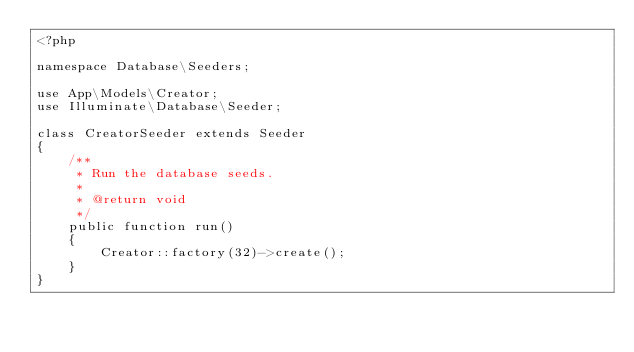Convert code to text. <code><loc_0><loc_0><loc_500><loc_500><_PHP_><?php

namespace Database\Seeders;

use App\Models\Creator;
use Illuminate\Database\Seeder;

class CreatorSeeder extends Seeder
{
    /**
     * Run the database seeds.
     *
     * @return void
     */
    public function run()
    {
        Creator::factory(32)->create();
    }
}
</code> 